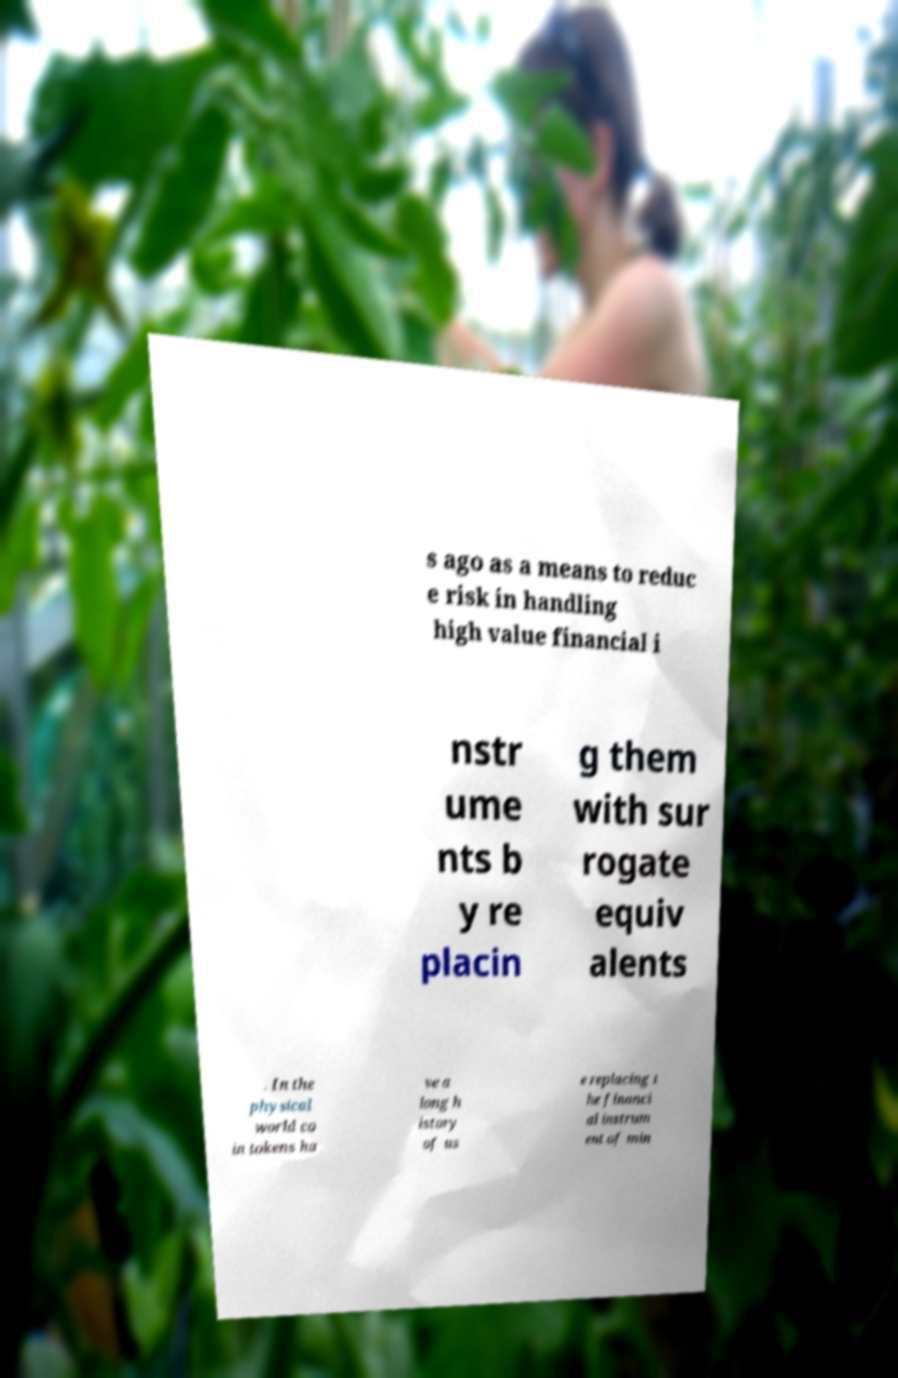Could you extract and type out the text from this image? s ago as a means to reduc e risk in handling high value financial i nstr ume nts b y re placin g them with sur rogate equiv alents . In the physical world co in tokens ha ve a long h istory of us e replacing t he financi al instrum ent of min 